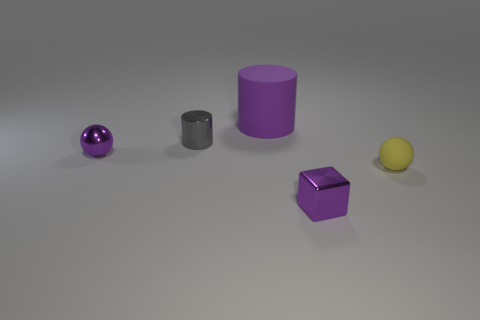Add 4 tiny matte things. How many objects exist? 9 Subtract all balls. How many objects are left? 3 Add 5 tiny purple shiny blocks. How many tiny purple shiny blocks are left? 6 Add 2 small blocks. How many small blocks exist? 3 Subtract 0 green spheres. How many objects are left? 5 Subtract all tiny cyan matte cylinders. Subtract all yellow matte balls. How many objects are left? 4 